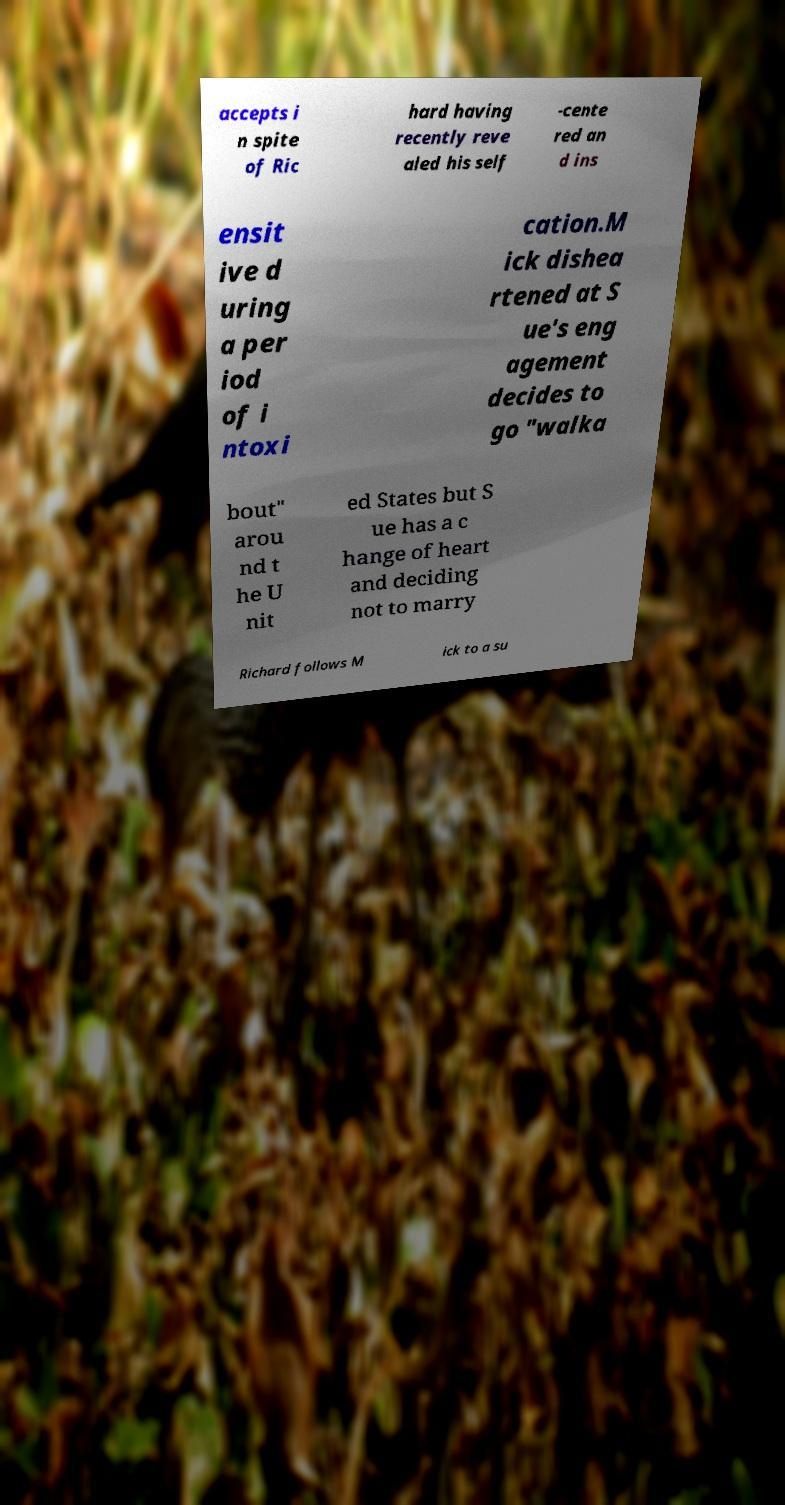Can you read and provide the text displayed in the image?This photo seems to have some interesting text. Can you extract and type it out for me? accepts i n spite of Ric hard having recently reve aled his self -cente red an d ins ensit ive d uring a per iod of i ntoxi cation.M ick dishea rtened at S ue's eng agement decides to go "walka bout" arou nd t he U nit ed States but S ue has a c hange of heart and deciding not to marry Richard follows M ick to a su 